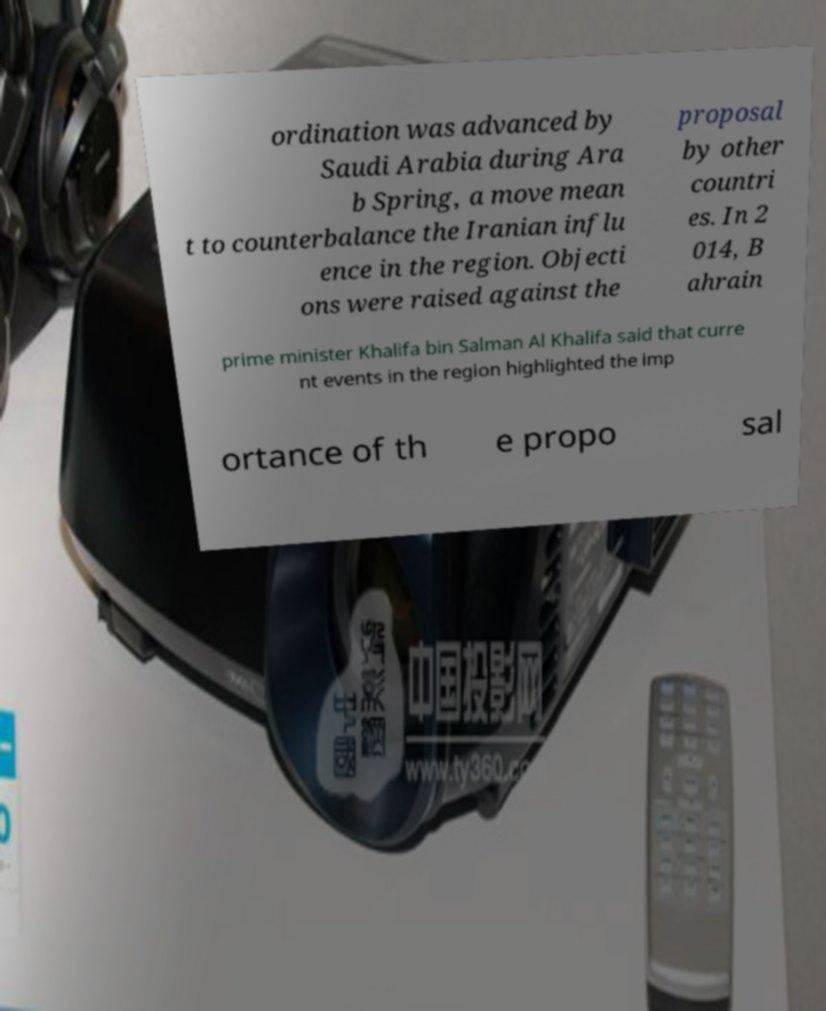Please read and relay the text visible in this image. What does it say? ordination was advanced by Saudi Arabia during Ara b Spring, a move mean t to counterbalance the Iranian influ ence in the region. Objecti ons were raised against the proposal by other countri es. In 2 014, B ahrain prime minister Khalifa bin Salman Al Khalifa said that curre nt events in the region highlighted the imp ortance of th e propo sal 